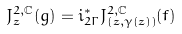Convert formula to latex. <formula><loc_0><loc_0><loc_500><loc_500>J ^ { 2 , \mathbb { C } } _ { z } ( g ) = i ^ { * } _ { 2 \Gamma } J ^ { 2 , \mathbb { C } } _ { ( z , \gamma ( z ) ) } ( f )</formula> 